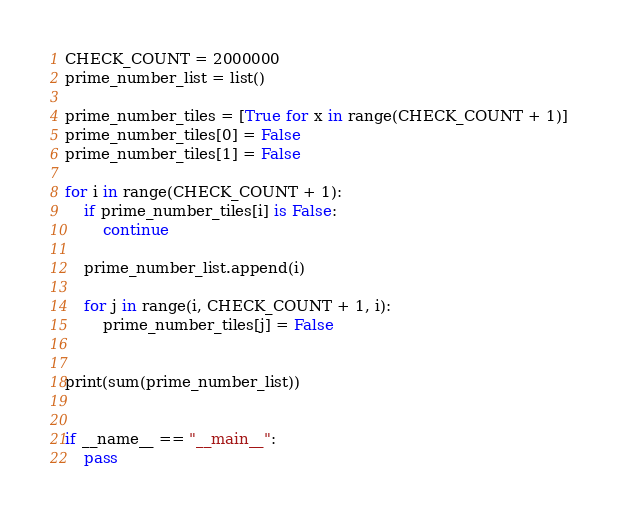Convert code to text. <code><loc_0><loc_0><loc_500><loc_500><_Python_>CHECK_COUNT = 2000000
prime_number_list = list()

prime_number_tiles = [True for x in range(CHECK_COUNT + 1)]
prime_number_tiles[0] = False
prime_number_tiles[1] = False

for i in range(CHECK_COUNT + 1):
    if prime_number_tiles[i] is False:
        continue

    prime_number_list.append(i)

    for j in range(i, CHECK_COUNT + 1, i):
        prime_number_tiles[j] = False


print(sum(prime_number_list))


if __name__ == "__main__":
    pass
</code> 